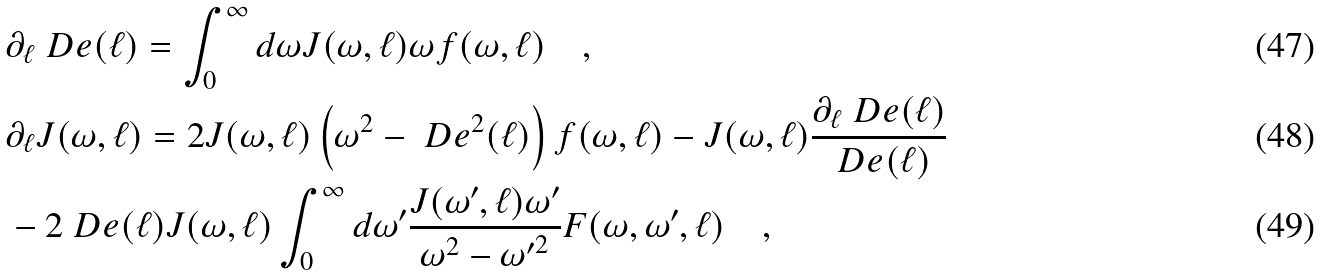<formula> <loc_0><loc_0><loc_500><loc_500>& \partial _ { \ell } \ D e ( \ell ) = \int _ { 0 } ^ { \infty } d \omega J ( \omega , \ell ) \omega f ( \omega , \ell ) \quad , \\ & \partial _ { \ell } J ( \omega , \ell ) = 2 J ( \omega , \ell ) \left ( \omega ^ { 2 } - \ D e ^ { 2 } ( \ell ) \right ) f ( \omega , \ell ) - J ( \omega , \ell ) \frac { \partial _ { \ell } \ D e ( \ell ) } { \ D e ( \ell ) } \\ & - 2 \ D e ( \ell ) J ( \omega , \ell ) \int _ { 0 } ^ { \infty } d \omega ^ { \prime } \frac { J ( \omega ^ { \prime } , \ell ) \omega ^ { \prime } } { \omega ^ { 2 } - { \omega ^ { \prime } } ^ { 2 } } F ( \omega , \omega ^ { \prime } , \ell ) \quad ,</formula> 